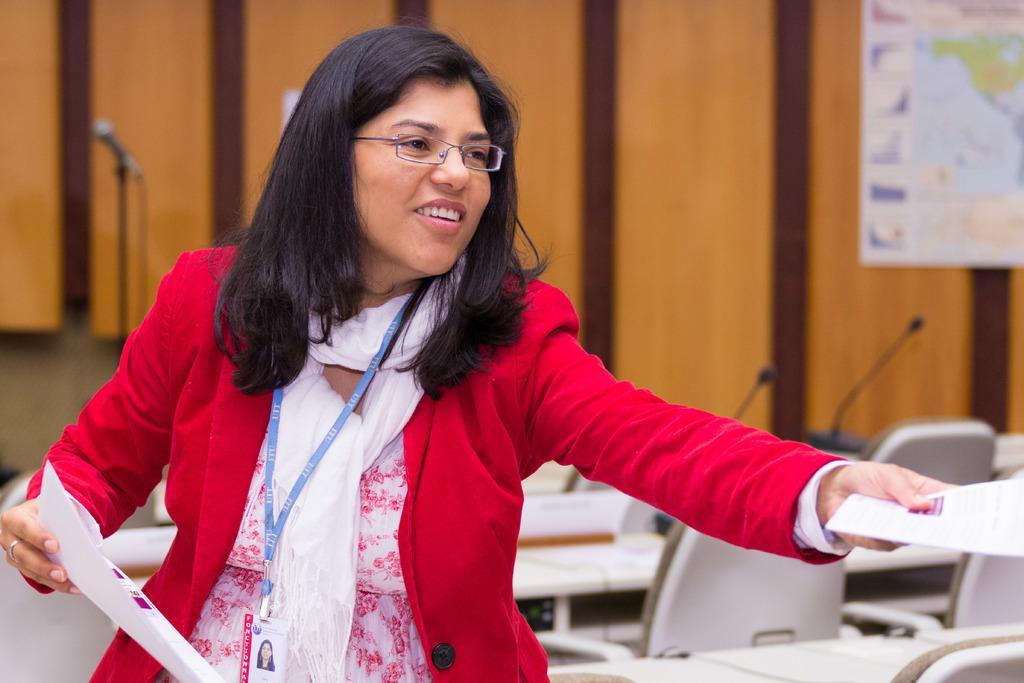Can you describe this image briefly? In this image I can see the person is holding the papers. Back I can see the chairs, few mice and few objects on the table. The board is attached to the brown color wall. 